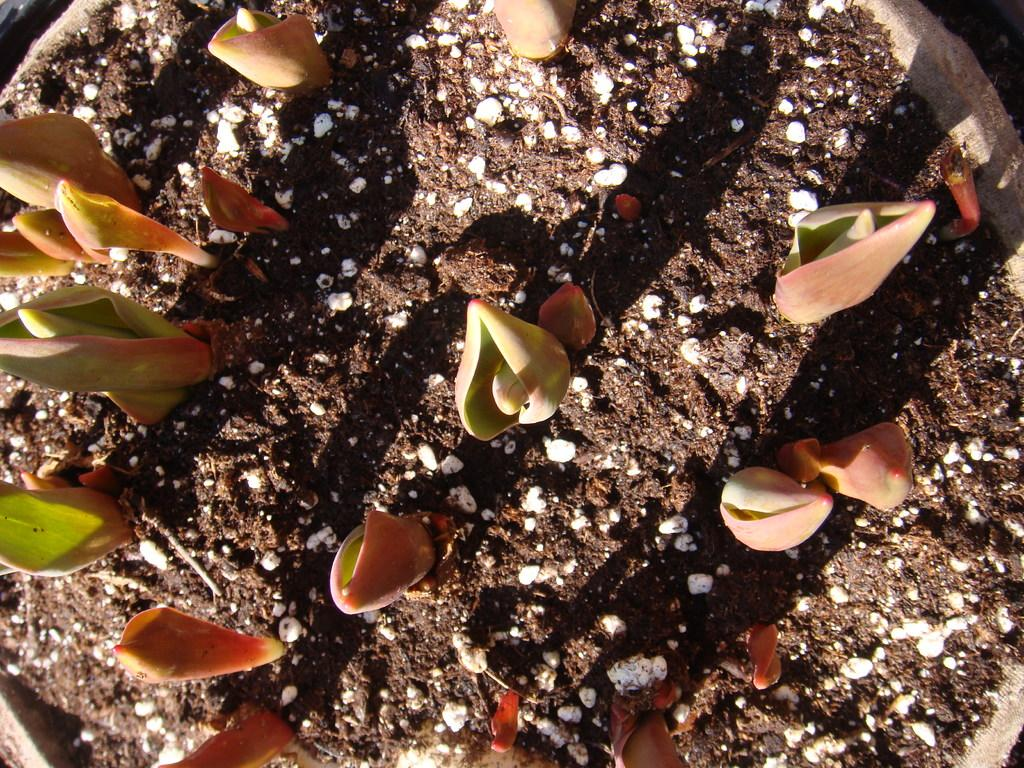What is the main object in the image? There is a pot in the image. What is inside the pot? There are seeds in the pot. Is the pot sinking in quicksand in the image? No, there is no quicksand present in the image, and the pot is not sinking. What type of apparatus is being used to water the seeds in the pot? There is no apparatus visible in the image for watering the seeds. 